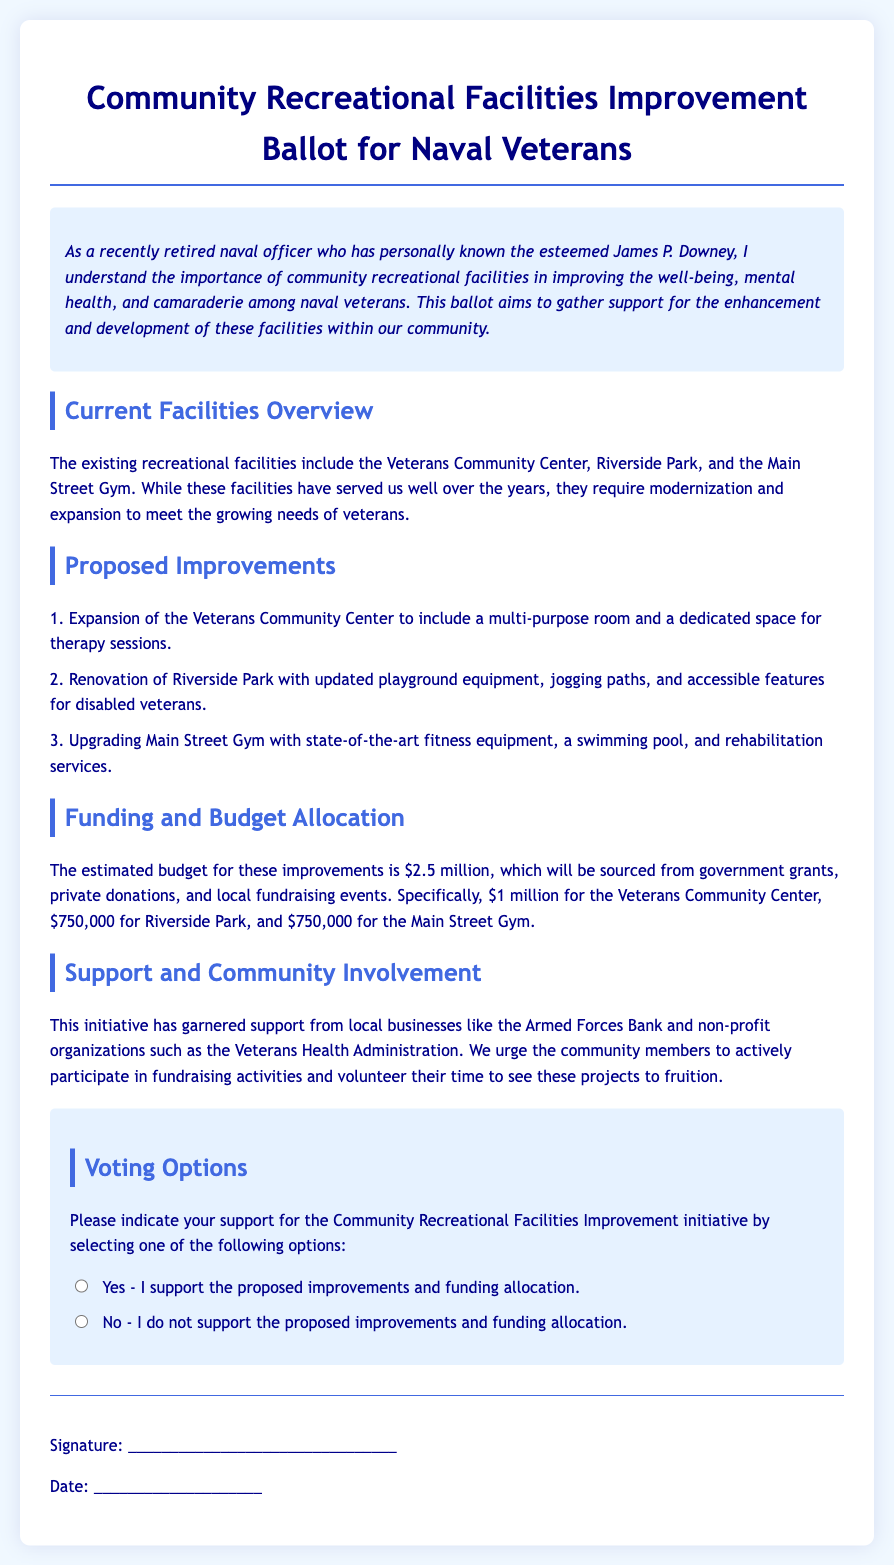What is the budget for the proposed improvements? The estimated budget for the proposed improvements is stated in the document as $2.5 million.
Answer: $2.5 million What is the proposed new feature for the Veterans Community Center? The document mentions the expansion of the Veterans Community Center to include a multi-purpose room and a dedicated space for therapy sessions.
Answer: Multi-purpose room and therapy space How much funding is allocated for Riverside Park? The specific funding allocation for Riverside Park is detailed in the document, which states it is $750,000.
Answer: $750,000 Who is mentioned as a supporter of this initiative? The document lists local businesses like the Armed Forces Bank and non-profit organizations such as the Veterans Health Administration as supporters of the initiative.
Answer: Armed Forces Bank What is a key purpose of this ballot? The document explains that the ballot aims to gather support for the enhancement and development of community recreational facilities for naval veterans.
Answer: Gather support What type of recreational facilities are highlighted in the ballot? The document highlights the Veterans Community Center, Riverside Park, and the Main Street Gym as existing recreational facilities.
Answer: Veterans Community Center, Riverside Park, Main Street Gym What method is suggested for funding the improvements? The document states that the budget will be sourced from government grants, private donations, and local fundraising events.
Answer: Government grants, private donations, local fundraising events What is the date placeholder for in the document? The date placeholder is where the signer should write the date when they sign the ballot.
Answer: Date of signature What action does the document encourage community members to take? The document urges community members to actively participate in fundraising activities and volunteer their time.
Answer: Participate in fundraising and volunteer 